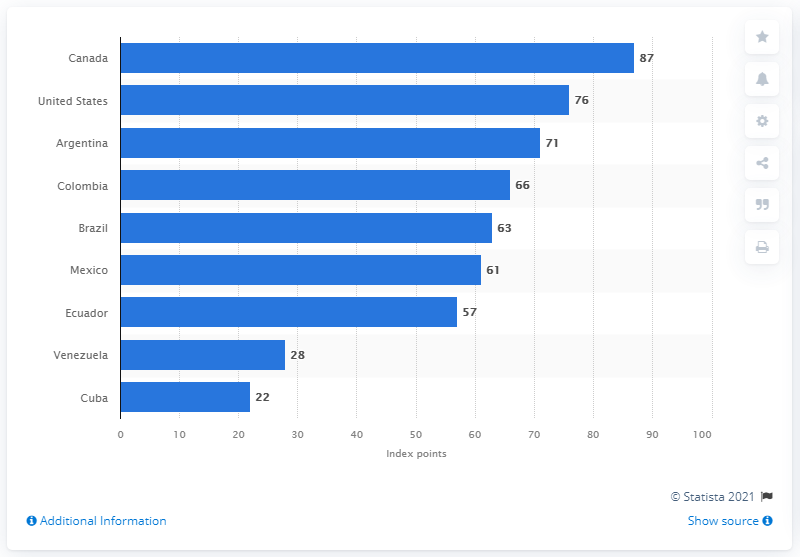Point out several critical features in this image. Cuba had 22 index points in 2020. In 2020, Canada had a score of 87 out of 100 on the index points. 